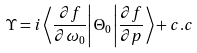<formula> <loc_0><loc_0><loc_500><loc_500>\Upsilon = i \left \langle \frac { \partial f } { \partial \omega _ { 0 } } \right | \Theta _ { 0 } \left | \frac { \partial f } { \partial p } \right \rangle + c . c</formula> 